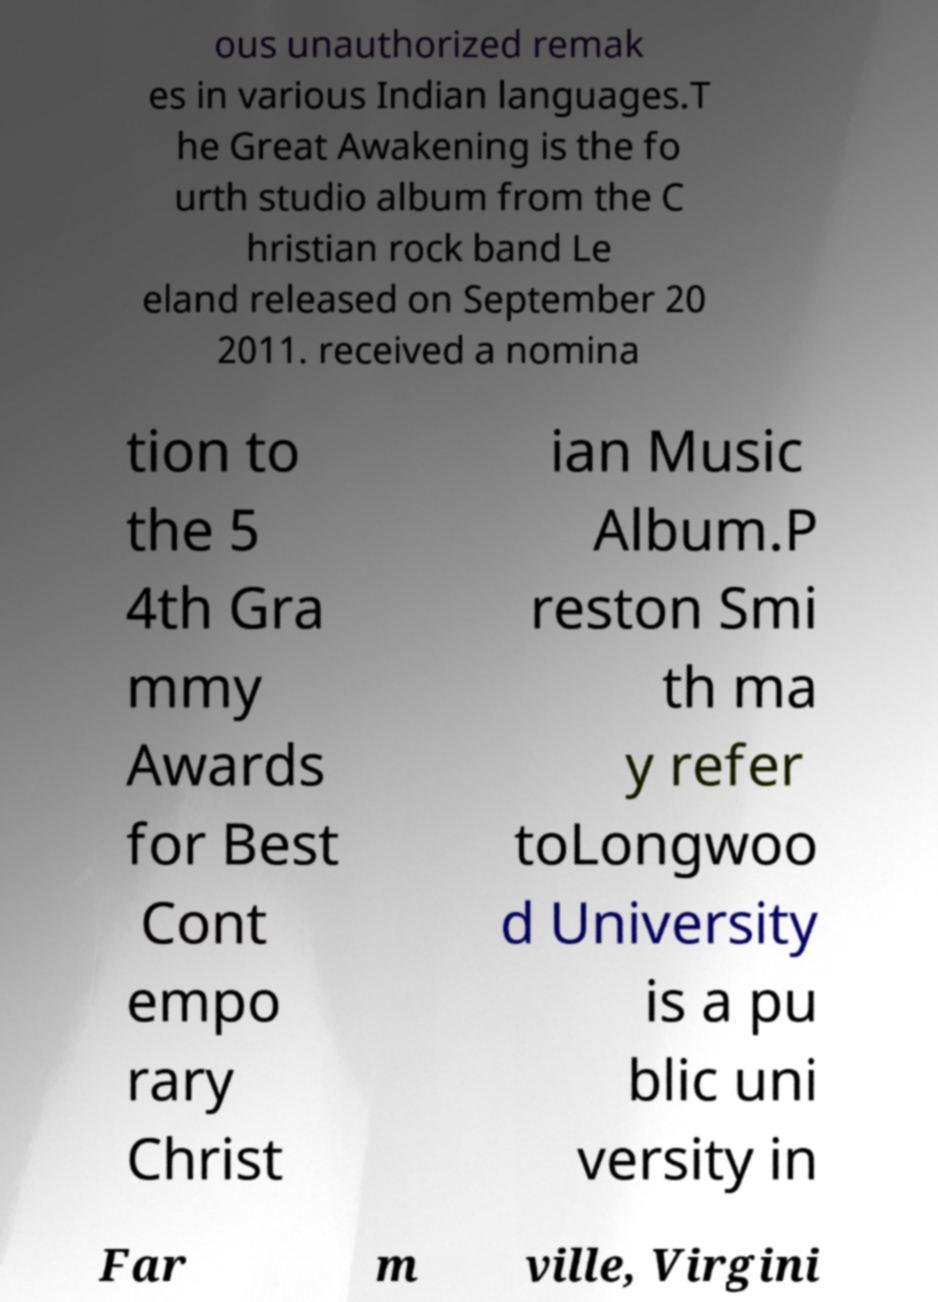There's text embedded in this image that I need extracted. Can you transcribe it verbatim? ous unauthorized remak es in various Indian languages.T he Great Awakening is the fo urth studio album from the C hristian rock band Le eland released on September 20 2011. received a nomina tion to the 5 4th Gra mmy Awards for Best Cont empo rary Christ ian Music Album.P reston Smi th ma y refer toLongwoo d University is a pu blic uni versity in Far m ville, Virgini 